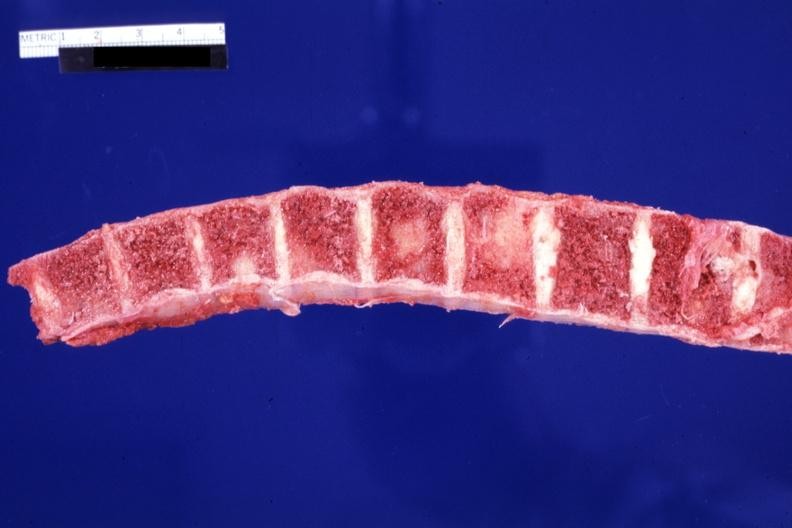does this image show several and large lesions?
Answer the question using a single word or phrase. Yes 